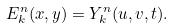Convert formula to latex. <formula><loc_0><loc_0><loc_500><loc_500>E _ { k } ^ { n } ( x , y ) = Y _ { k } ^ { n } ( u , v , t ) .</formula> 